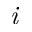<formula> <loc_0><loc_0><loc_500><loc_500>i</formula> 